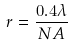<formula> <loc_0><loc_0><loc_500><loc_500>r = \frac { 0 . 4 \lambda } { N A }</formula> 